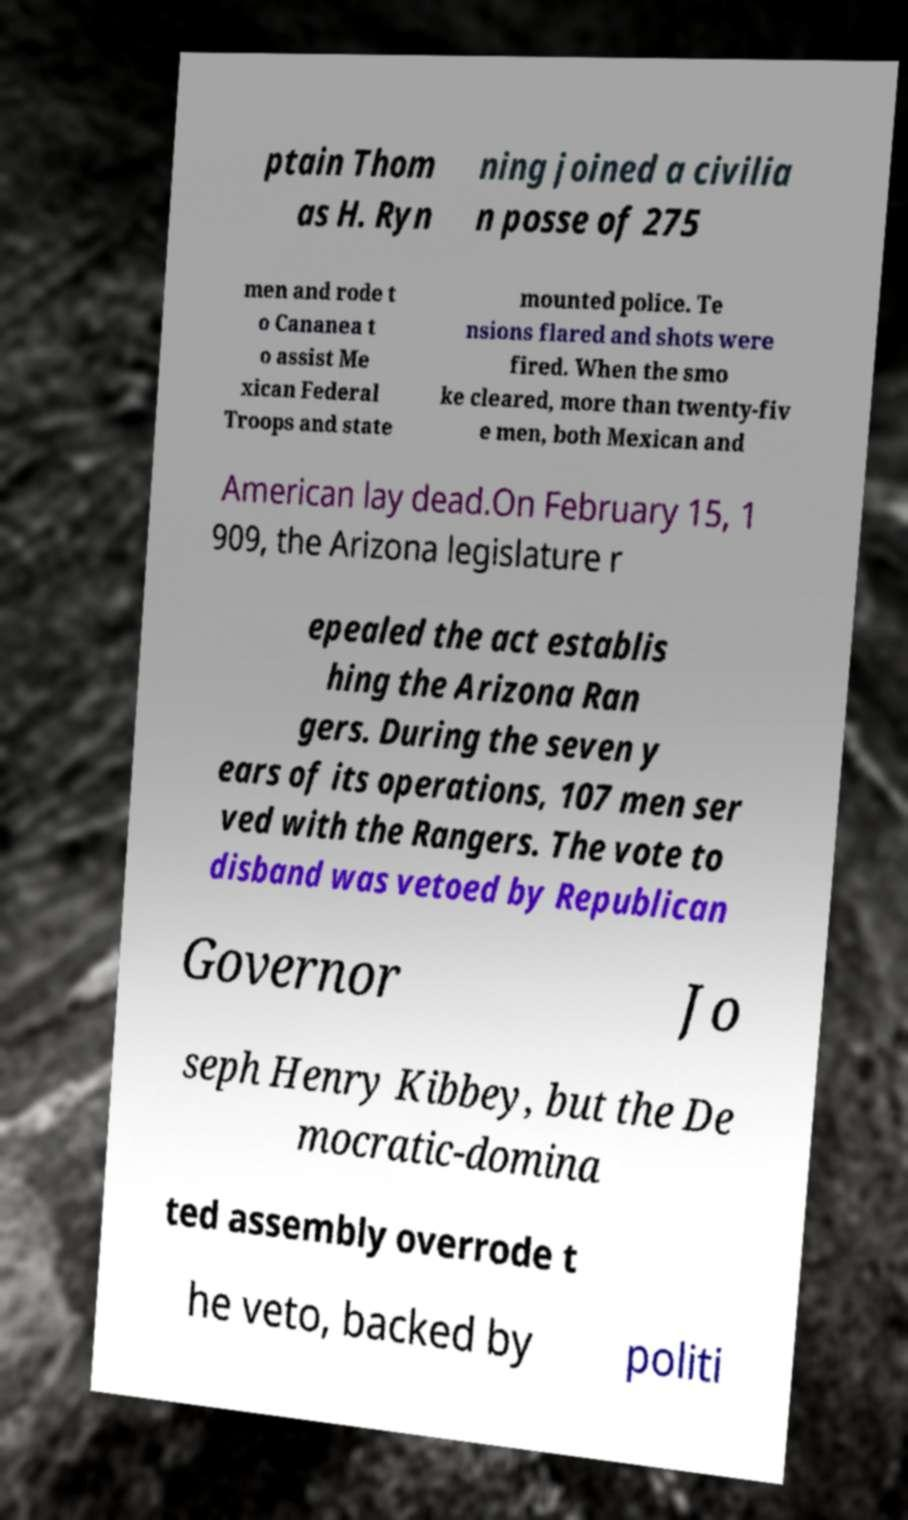What messages or text are displayed in this image? I need them in a readable, typed format. ptain Thom as H. Ryn ning joined a civilia n posse of 275 men and rode t o Cananea t o assist Me xican Federal Troops and state mounted police. Te nsions flared and shots were fired. When the smo ke cleared, more than twenty-fiv e men, both Mexican and American lay dead.On February 15, 1 909, the Arizona legislature r epealed the act establis hing the Arizona Ran gers. During the seven y ears of its operations, 107 men ser ved with the Rangers. The vote to disband was vetoed by Republican Governor Jo seph Henry Kibbey, but the De mocratic-domina ted assembly overrode t he veto, backed by politi 